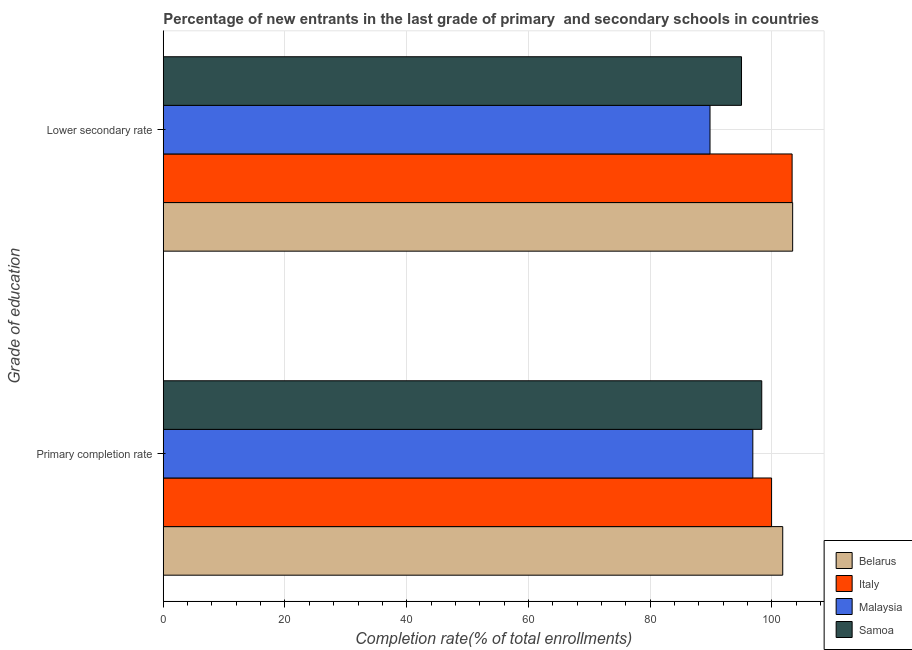How many different coloured bars are there?
Your answer should be very brief. 4. How many groups of bars are there?
Your response must be concise. 2. Are the number of bars per tick equal to the number of legend labels?
Offer a very short reply. Yes. Are the number of bars on each tick of the Y-axis equal?
Give a very brief answer. Yes. What is the label of the 2nd group of bars from the top?
Your answer should be very brief. Primary completion rate. What is the completion rate in secondary schools in Samoa?
Give a very brief answer. 95.01. Across all countries, what is the maximum completion rate in secondary schools?
Give a very brief answer. 103.42. Across all countries, what is the minimum completion rate in primary schools?
Offer a terse response. 96.87. In which country was the completion rate in primary schools maximum?
Your answer should be compact. Belarus. In which country was the completion rate in primary schools minimum?
Your answer should be very brief. Malaysia. What is the total completion rate in secondary schools in the graph?
Provide a short and direct response. 391.59. What is the difference between the completion rate in primary schools in Malaysia and that in Samoa?
Your response must be concise. -1.47. What is the difference between the completion rate in primary schools in Italy and the completion rate in secondary schools in Samoa?
Make the answer very short. 4.94. What is the average completion rate in primary schools per country?
Your response must be concise. 99.24. What is the difference between the completion rate in primary schools and completion rate in secondary schools in Samoa?
Make the answer very short. 3.32. What is the ratio of the completion rate in primary schools in Belarus to that in Samoa?
Your response must be concise. 1.04. Is the completion rate in secondary schools in Italy less than that in Belarus?
Your answer should be compact. Yes. What does the 2nd bar from the top in Primary completion rate represents?
Your answer should be very brief. Malaysia. What does the 1st bar from the bottom in Lower secondary rate represents?
Offer a very short reply. Belarus. Are all the bars in the graph horizontal?
Your answer should be very brief. Yes. What is the difference between two consecutive major ticks on the X-axis?
Make the answer very short. 20. Does the graph contain grids?
Provide a succinct answer. Yes. Where does the legend appear in the graph?
Give a very brief answer. Bottom right. How many legend labels are there?
Your answer should be compact. 4. How are the legend labels stacked?
Offer a very short reply. Vertical. What is the title of the graph?
Your answer should be compact. Percentage of new entrants in the last grade of primary  and secondary schools in countries. Does "Venezuela" appear as one of the legend labels in the graph?
Give a very brief answer. No. What is the label or title of the X-axis?
Your answer should be compact. Completion rate(% of total enrollments). What is the label or title of the Y-axis?
Your answer should be compact. Grade of education. What is the Completion rate(% of total enrollments) in Belarus in Primary completion rate?
Keep it short and to the point. 101.79. What is the Completion rate(% of total enrollments) in Italy in Primary completion rate?
Ensure brevity in your answer.  99.95. What is the Completion rate(% of total enrollments) in Malaysia in Primary completion rate?
Your answer should be very brief. 96.87. What is the Completion rate(% of total enrollments) in Samoa in Primary completion rate?
Provide a short and direct response. 98.34. What is the Completion rate(% of total enrollments) of Belarus in Lower secondary rate?
Keep it short and to the point. 103.42. What is the Completion rate(% of total enrollments) of Italy in Lower secondary rate?
Keep it short and to the point. 103.32. What is the Completion rate(% of total enrollments) in Malaysia in Lower secondary rate?
Make the answer very short. 89.84. What is the Completion rate(% of total enrollments) in Samoa in Lower secondary rate?
Your answer should be very brief. 95.01. Across all Grade of education, what is the maximum Completion rate(% of total enrollments) of Belarus?
Make the answer very short. 103.42. Across all Grade of education, what is the maximum Completion rate(% of total enrollments) in Italy?
Make the answer very short. 103.32. Across all Grade of education, what is the maximum Completion rate(% of total enrollments) in Malaysia?
Provide a short and direct response. 96.87. Across all Grade of education, what is the maximum Completion rate(% of total enrollments) of Samoa?
Make the answer very short. 98.34. Across all Grade of education, what is the minimum Completion rate(% of total enrollments) of Belarus?
Your answer should be very brief. 101.79. Across all Grade of education, what is the minimum Completion rate(% of total enrollments) in Italy?
Provide a succinct answer. 99.95. Across all Grade of education, what is the minimum Completion rate(% of total enrollments) in Malaysia?
Offer a terse response. 89.84. Across all Grade of education, what is the minimum Completion rate(% of total enrollments) in Samoa?
Your answer should be very brief. 95.01. What is the total Completion rate(% of total enrollments) of Belarus in the graph?
Your response must be concise. 205.2. What is the total Completion rate(% of total enrollments) of Italy in the graph?
Your answer should be very brief. 203.28. What is the total Completion rate(% of total enrollments) in Malaysia in the graph?
Make the answer very short. 186.71. What is the total Completion rate(% of total enrollments) of Samoa in the graph?
Offer a terse response. 193.35. What is the difference between the Completion rate(% of total enrollments) of Belarus in Primary completion rate and that in Lower secondary rate?
Keep it short and to the point. -1.63. What is the difference between the Completion rate(% of total enrollments) in Italy in Primary completion rate and that in Lower secondary rate?
Provide a short and direct response. -3.37. What is the difference between the Completion rate(% of total enrollments) in Malaysia in Primary completion rate and that in Lower secondary rate?
Offer a very short reply. 7.03. What is the difference between the Completion rate(% of total enrollments) in Samoa in Primary completion rate and that in Lower secondary rate?
Offer a very short reply. 3.32. What is the difference between the Completion rate(% of total enrollments) of Belarus in Primary completion rate and the Completion rate(% of total enrollments) of Italy in Lower secondary rate?
Offer a very short reply. -1.54. What is the difference between the Completion rate(% of total enrollments) of Belarus in Primary completion rate and the Completion rate(% of total enrollments) of Malaysia in Lower secondary rate?
Ensure brevity in your answer.  11.95. What is the difference between the Completion rate(% of total enrollments) in Belarus in Primary completion rate and the Completion rate(% of total enrollments) in Samoa in Lower secondary rate?
Your answer should be very brief. 6.77. What is the difference between the Completion rate(% of total enrollments) in Italy in Primary completion rate and the Completion rate(% of total enrollments) in Malaysia in Lower secondary rate?
Offer a very short reply. 10.12. What is the difference between the Completion rate(% of total enrollments) in Italy in Primary completion rate and the Completion rate(% of total enrollments) in Samoa in Lower secondary rate?
Your answer should be compact. 4.94. What is the difference between the Completion rate(% of total enrollments) in Malaysia in Primary completion rate and the Completion rate(% of total enrollments) in Samoa in Lower secondary rate?
Make the answer very short. 1.86. What is the average Completion rate(% of total enrollments) in Belarus per Grade of education?
Provide a short and direct response. 102.6. What is the average Completion rate(% of total enrollments) in Italy per Grade of education?
Make the answer very short. 101.64. What is the average Completion rate(% of total enrollments) of Malaysia per Grade of education?
Provide a succinct answer. 93.35. What is the average Completion rate(% of total enrollments) of Samoa per Grade of education?
Offer a terse response. 96.67. What is the difference between the Completion rate(% of total enrollments) in Belarus and Completion rate(% of total enrollments) in Italy in Primary completion rate?
Keep it short and to the point. 1.83. What is the difference between the Completion rate(% of total enrollments) of Belarus and Completion rate(% of total enrollments) of Malaysia in Primary completion rate?
Give a very brief answer. 4.92. What is the difference between the Completion rate(% of total enrollments) in Belarus and Completion rate(% of total enrollments) in Samoa in Primary completion rate?
Make the answer very short. 3.45. What is the difference between the Completion rate(% of total enrollments) of Italy and Completion rate(% of total enrollments) of Malaysia in Primary completion rate?
Your answer should be compact. 3.08. What is the difference between the Completion rate(% of total enrollments) of Italy and Completion rate(% of total enrollments) of Samoa in Primary completion rate?
Your response must be concise. 1.62. What is the difference between the Completion rate(% of total enrollments) of Malaysia and Completion rate(% of total enrollments) of Samoa in Primary completion rate?
Your answer should be very brief. -1.47. What is the difference between the Completion rate(% of total enrollments) of Belarus and Completion rate(% of total enrollments) of Italy in Lower secondary rate?
Keep it short and to the point. 0.09. What is the difference between the Completion rate(% of total enrollments) of Belarus and Completion rate(% of total enrollments) of Malaysia in Lower secondary rate?
Your response must be concise. 13.58. What is the difference between the Completion rate(% of total enrollments) of Belarus and Completion rate(% of total enrollments) of Samoa in Lower secondary rate?
Provide a short and direct response. 8.4. What is the difference between the Completion rate(% of total enrollments) of Italy and Completion rate(% of total enrollments) of Malaysia in Lower secondary rate?
Your answer should be very brief. 13.49. What is the difference between the Completion rate(% of total enrollments) of Italy and Completion rate(% of total enrollments) of Samoa in Lower secondary rate?
Your response must be concise. 8.31. What is the difference between the Completion rate(% of total enrollments) of Malaysia and Completion rate(% of total enrollments) of Samoa in Lower secondary rate?
Provide a short and direct response. -5.18. What is the ratio of the Completion rate(% of total enrollments) in Belarus in Primary completion rate to that in Lower secondary rate?
Your response must be concise. 0.98. What is the ratio of the Completion rate(% of total enrollments) of Italy in Primary completion rate to that in Lower secondary rate?
Keep it short and to the point. 0.97. What is the ratio of the Completion rate(% of total enrollments) of Malaysia in Primary completion rate to that in Lower secondary rate?
Offer a terse response. 1.08. What is the ratio of the Completion rate(% of total enrollments) in Samoa in Primary completion rate to that in Lower secondary rate?
Provide a short and direct response. 1.03. What is the difference between the highest and the second highest Completion rate(% of total enrollments) of Belarus?
Make the answer very short. 1.63. What is the difference between the highest and the second highest Completion rate(% of total enrollments) in Italy?
Your response must be concise. 3.37. What is the difference between the highest and the second highest Completion rate(% of total enrollments) of Malaysia?
Ensure brevity in your answer.  7.03. What is the difference between the highest and the second highest Completion rate(% of total enrollments) in Samoa?
Your answer should be very brief. 3.32. What is the difference between the highest and the lowest Completion rate(% of total enrollments) of Belarus?
Provide a succinct answer. 1.63. What is the difference between the highest and the lowest Completion rate(% of total enrollments) in Italy?
Your answer should be compact. 3.37. What is the difference between the highest and the lowest Completion rate(% of total enrollments) in Malaysia?
Your answer should be compact. 7.03. What is the difference between the highest and the lowest Completion rate(% of total enrollments) of Samoa?
Your answer should be very brief. 3.32. 